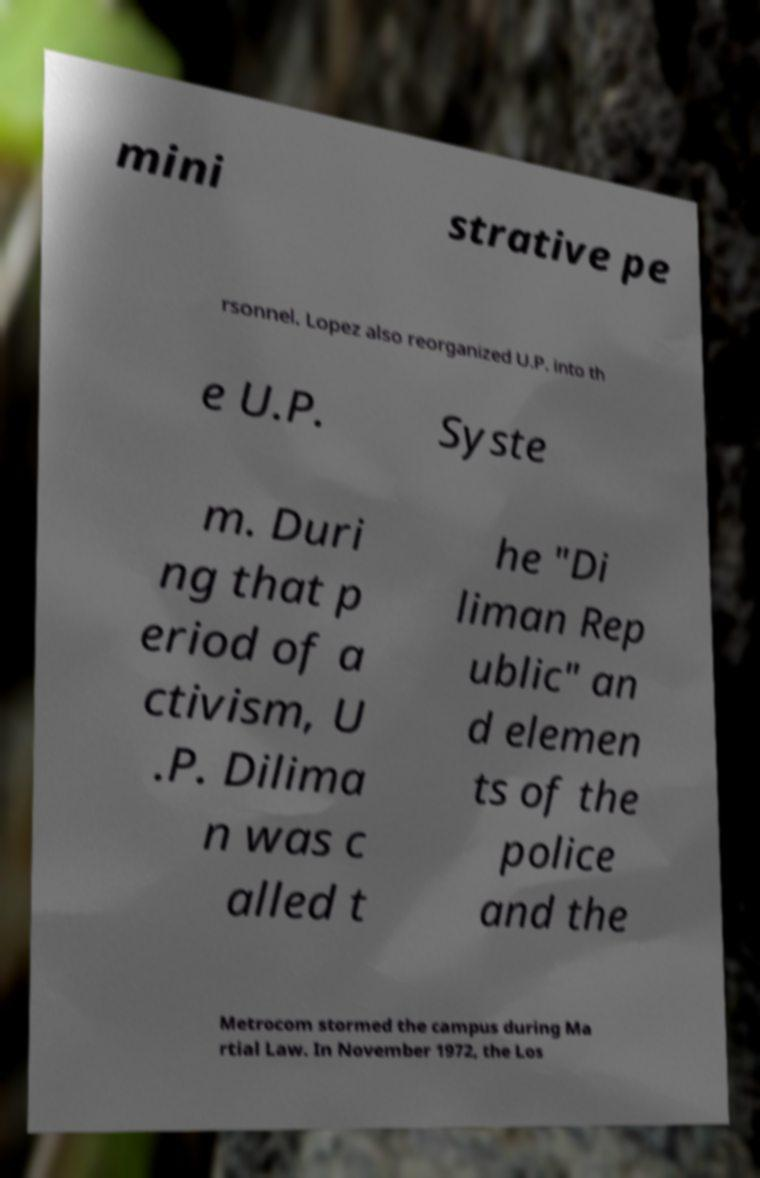Please read and relay the text visible in this image. What does it say? mini strative pe rsonnel. Lopez also reorganized U.P. into th e U.P. Syste m. Duri ng that p eriod of a ctivism, U .P. Dilima n was c alled t he "Di liman Rep ublic" an d elemen ts of the police and the Metrocom stormed the campus during Ma rtial Law. In November 1972, the Los 